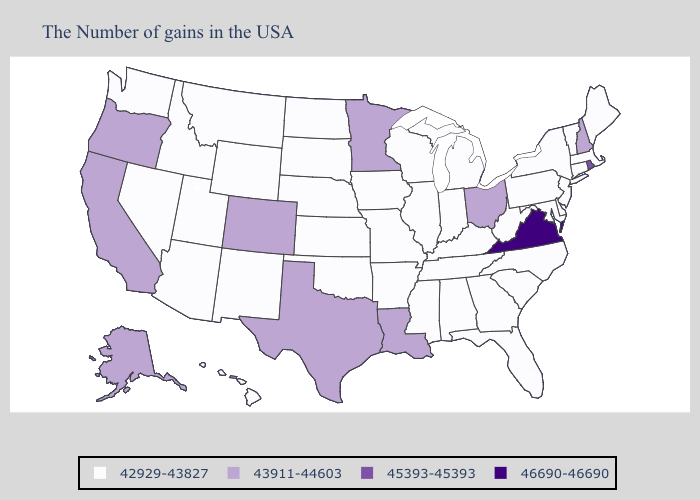Name the states that have a value in the range 45393-45393?
Short answer required. Rhode Island. What is the highest value in the Northeast ?
Quick response, please. 45393-45393. Among the states that border Washington , does Oregon have the highest value?
Keep it brief. Yes. Does Connecticut have a lower value than Indiana?
Give a very brief answer. No. Name the states that have a value in the range 43911-44603?
Be succinct. New Hampshire, Ohio, Louisiana, Minnesota, Texas, Colorado, California, Oregon, Alaska. Which states have the lowest value in the USA?
Be succinct. Maine, Massachusetts, Vermont, Connecticut, New York, New Jersey, Delaware, Maryland, Pennsylvania, North Carolina, South Carolina, West Virginia, Florida, Georgia, Michigan, Kentucky, Indiana, Alabama, Tennessee, Wisconsin, Illinois, Mississippi, Missouri, Arkansas, Iowa, Kansas, Nebraska, Oklahoma, South Dakota, North Dakota, Wyoming, New Mexico, Utah, Montana, Arizona, Idaho, Nevada, Washington, Hawaii. Name the states that have a value in the range 43911-44603?
Give a very brief answer. New Hampshire, Ohio, Louisiana, Minnesota, Texas, Colorado, California, Oregon, Alaska. What is the value of New Mexico?
Concise answer only. 42929-43827. Name the states that have a value in the range 42929-43827?
Be succinct. Maine, Massachusetts, Vermont, Connecticut, New York, New Jersey, Delaware, Maryland, Pennsylvania, North Carolina, South Carolina, West Virginia, Florida, Georgia, Michigan, Kentucky, Indiana, Alabama, Tennessee, Wisconsin, Illinois, Mississippi, Missouri, Arkansas, Iowa, Kansas, Nebraska, Oklahoma, South Dakota, North Dakota, Wyoming, New Mexico, Utah, Montana, Arizona, Idaho, Nevada, Washington, Hawaii. What is the value of New Jersey?
Keep it brief. 42929-43827. Name the states that have a value in the range 46690-46690?
Keep it brief. Virginia. Which states have the lowest value in the USA?
Concise answer only. Maine, Massachusetts, Vermont, Connecticut, New York, New Jersey, Delaware, Maryland, Pennsylvania, North Carolina, South Carolina, West Virginia, Florida, Georgia, Michigan, Kentucky, Indiana, Alabama, Tennessee, Wisconsin, Illinois, Mississippi, Missouri, Arkansas, Iowa, Kansas, Nebraska, Oklahoma, South Dakota, North Dakota, Wyoming, New Mexico, Utah, Montana, Arizona, Idaho, Nevada, Washington, Hawaii. Does Virginia have the lowest value in the South?
Keep it brief. No. Among the states that border South Carolina , which have the lowest value?
Answer briefly. North Carolina, Georgia. 